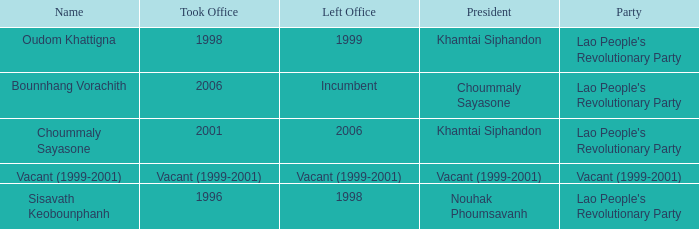What is Name, when President is Khamtai Siphandon, and when Left Office is 1999? Oudom Khattigna. 